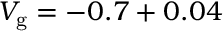Convert formula to latex. <formula><loc_0><loc_0><loc_500><loc_500>V _ { g } = - 0 . 7 + 0 . 0 4</formula> 